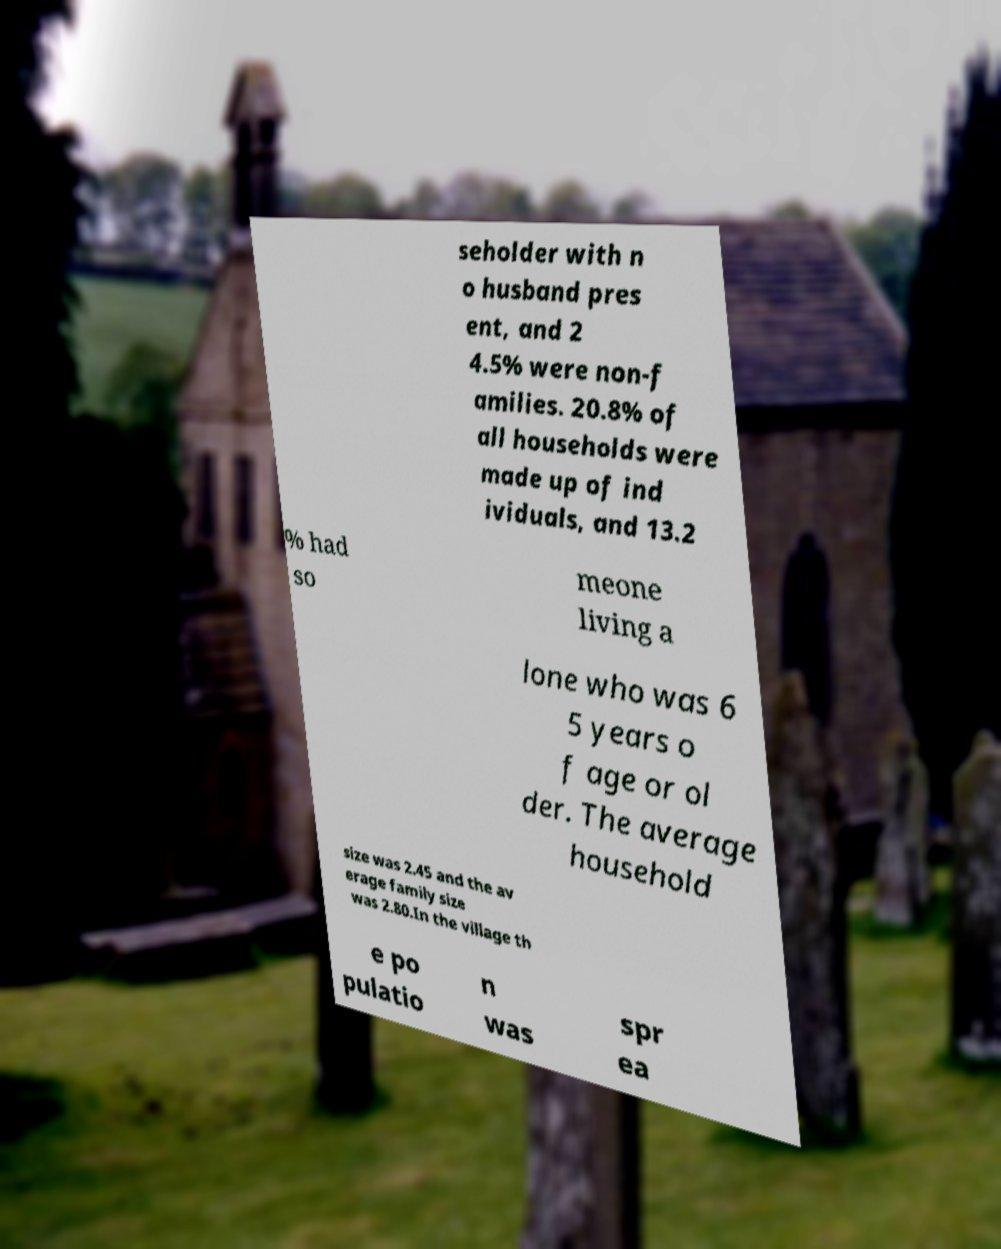Please identify and transcribe the text found in this image. seholder with n o husband pres ent, and 2 4.5% were non-f amilies. 20.8% of all households were made up of ind ividuals, and 13.2 % had so meone living a lone who was 6 5 years o f age or ol der. The average household size was 2.45 and the av erage family size was 2.80.In the village th e po pulatio n was spr ea 